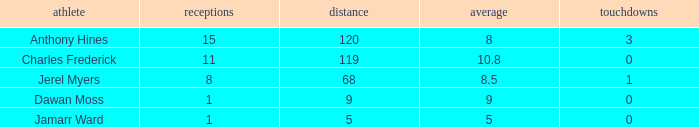What is the average number of TDs when the yards are less than 119, the AVG is larger than 5, and Jamarr Ward is a player? None. 